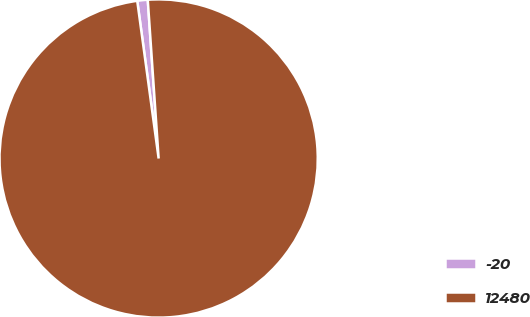Convert chart. <chart><loc_0><loc_0><loc_500><loc_500><pie_chart><fcel>-20<fcel>12480<nl><fcel>1.06%<fcel>98.94%<nl></chart> 